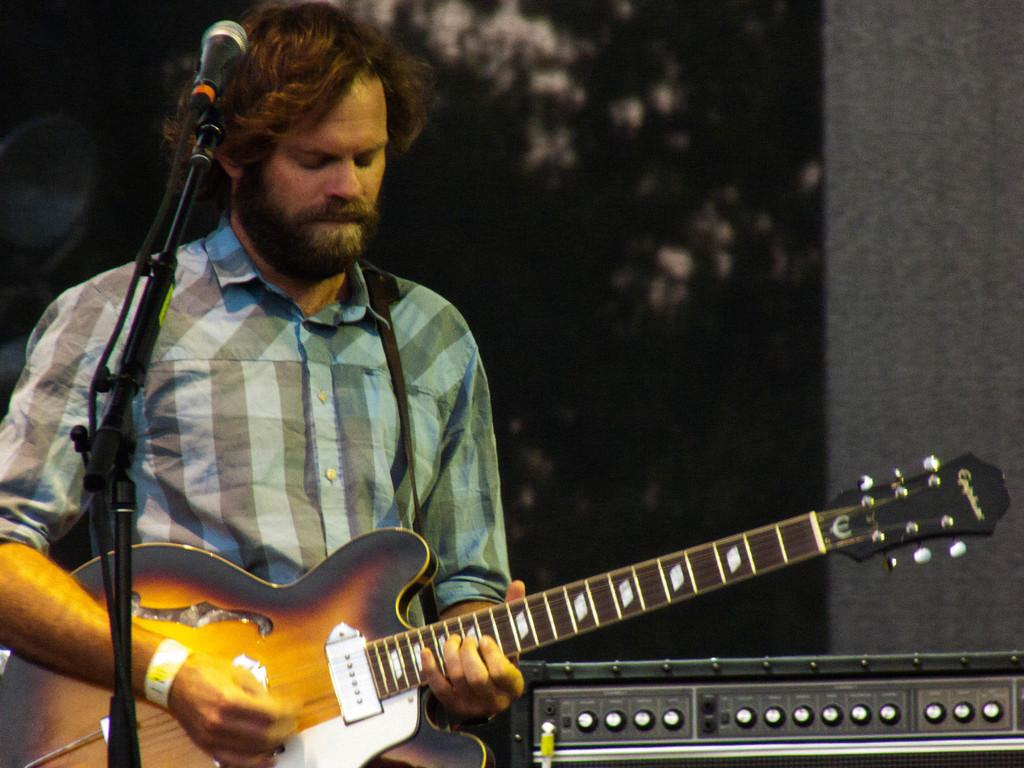What is the man in the image doing? The man is playing a guitar in the image. What object is present in the image that is commonly used for amplifying sound? There is a microphone (mike) in the image. What type of beef is the man eating in the image? There is no beef present in the image; the man is playing a guitar. What emotion is the man displaying in the image? The man's emotion cannot be determined from the image, as only his activity of playing a guitar is visible. 